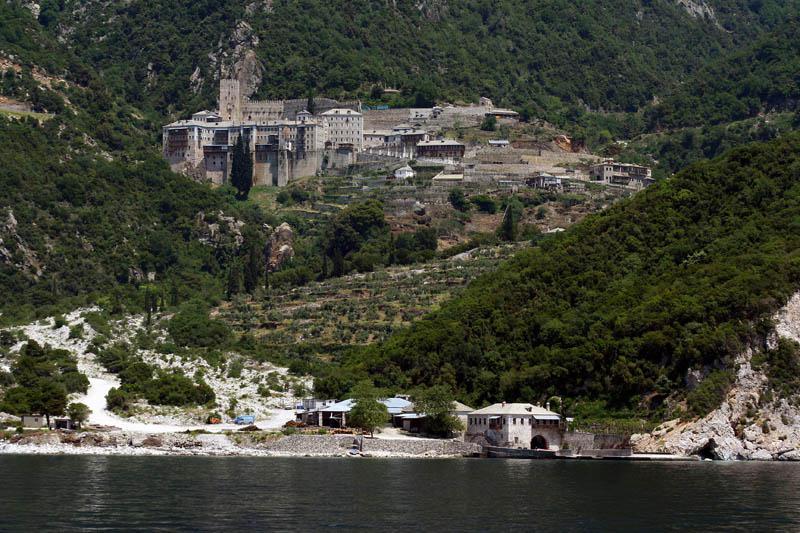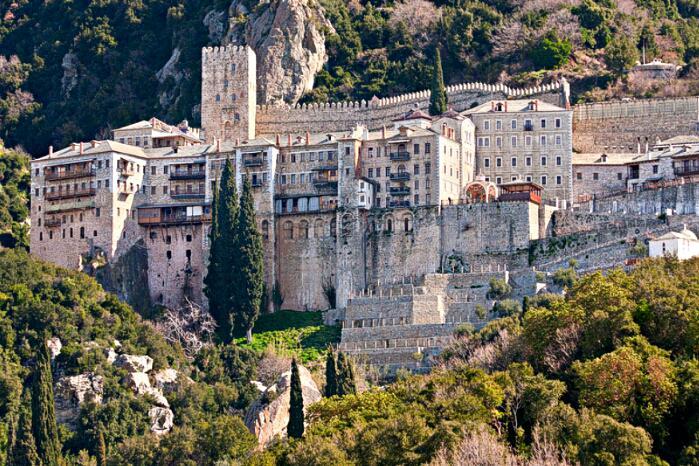The first image is the image on the left, the second image is the image on the right. Evaluate the accuracy of this statement regarding the images: "there is water in the image on the right". Is it true? Answer yes or no. No. The first image is the image on the left, the second image is the image on the right. Given the left and right images, does the statement "Only one of the images show a body of water." hold true? Answer yes or no. Yes. 